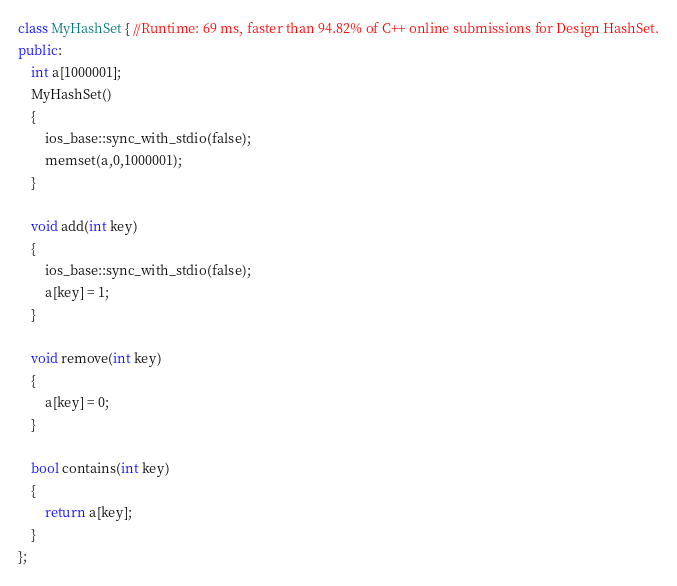Convert code to text. <code><loc_0><loc_0><loc_500><loc_500><_C++_>class MyHashSet { //Runtime: 69 ms, faster than 94.82% of C++ online submissions for Design HashSet.
public:
    int a[1000001];
    MyHashSet() 
    {
        ios_base::sync_with_stdio(false);
        memset(a,0,1000001);
    }
    
    void add(int key) 
    {
        ios_base::sync_with_stdio(false);
        a[key] = 1;
    }
    
    void remove(int key) 
    {
        a[key] = 0;
    }
    
    bool contains(int key) 
    {
        return a[key];
    }
};
</code> 